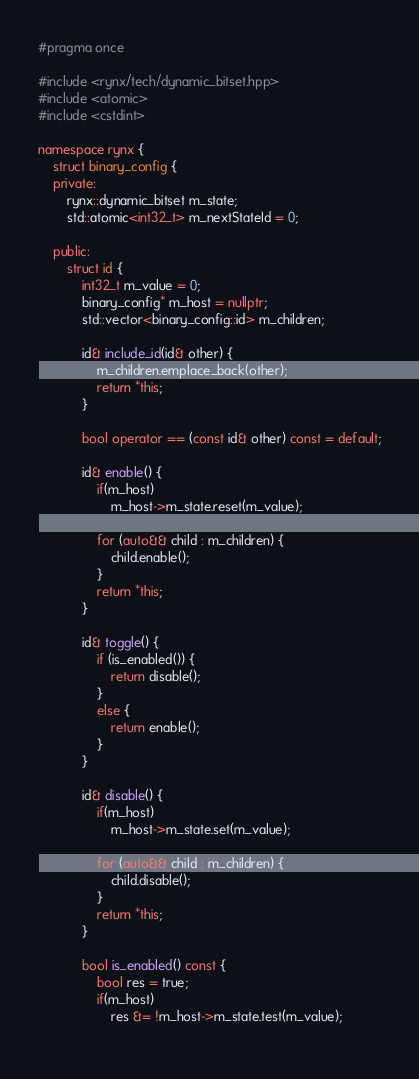<code> <loc_0><loc_0><loc_500><loc_500><_C++_>#pragma once

#include <rynx/tech/dynamic_bitset.hpp>
#include <atomic>
#include <cstdint>

namespace rynx {
	struct binary_config {
	private:
		rynx::dynamic_bitset m_state;
		std::atomic<int32_t> m_nextStateId = 0;

	public:
		struct id {
			int32_t m_value = 0;
			binary_config* m_host = nullptr;
			std::vector<binary_config::id> m_children;

			id& include_id(id& other) {
				m_children.emplace_back(other);
				return *this;
			}

			bool operator == (const id& other) const = default;

			id& enable() {
				if(m_host)
					m_host->m_state.reset(m_value);
				
				for (auto&& child : m_children) {
					child.enable();
				}
				return *this;
			}

			id& toggle() {
				if (is_enabled()) {
					return disable();
				}
				else {
					return enable();
				}
			}

			id& disable() {
				if(m_host)
					m_host->m_state.set(m_value);
				
				for (auto&& child : m_children) {
					child.disable();
				}
				return *this;
			}

			bool is_enabled() const {
				bool res = true;
				if(m_host)
					res &= !m_host->m_state.test(m_value);
				</code> 